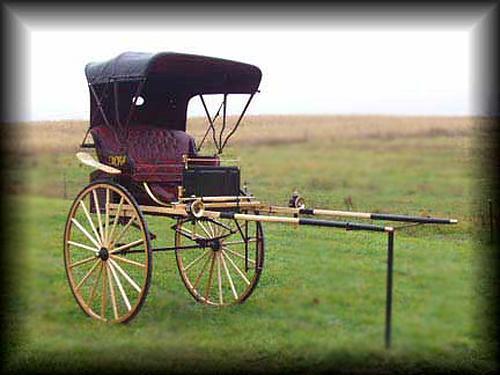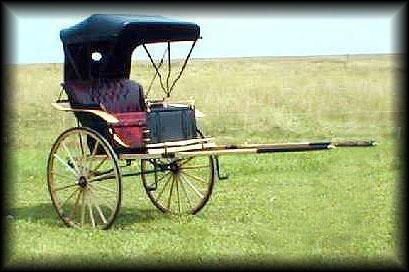The first image is the image on the left, the second image is the image on the right. For the images shown, is this caption "There is a carriage next to a paved road in the left image." true? Answer yes or no. No. The first image is the image on the left, the second image is the image on the right. Evaluate the accuracy of this statement regarding the images: "Both carriages are facing right.". Is it true? Answer yes or no. Yes. 